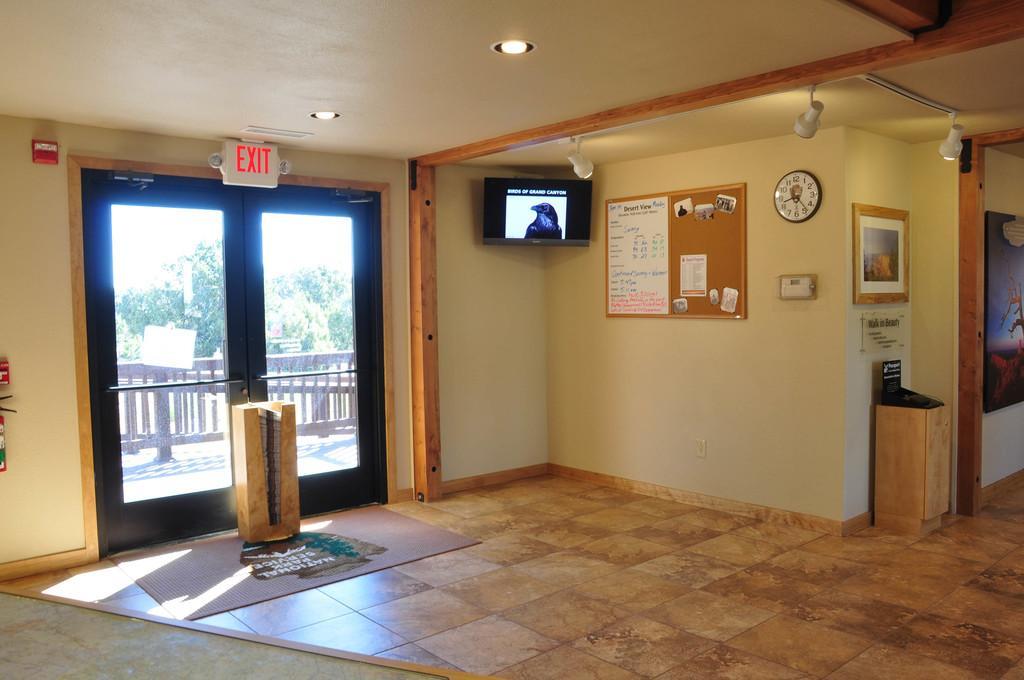Describe this image in one or two sentences. In this image we can see door, television, board, clock, photo frame, lights and behind the door we can see a fence and trees. 